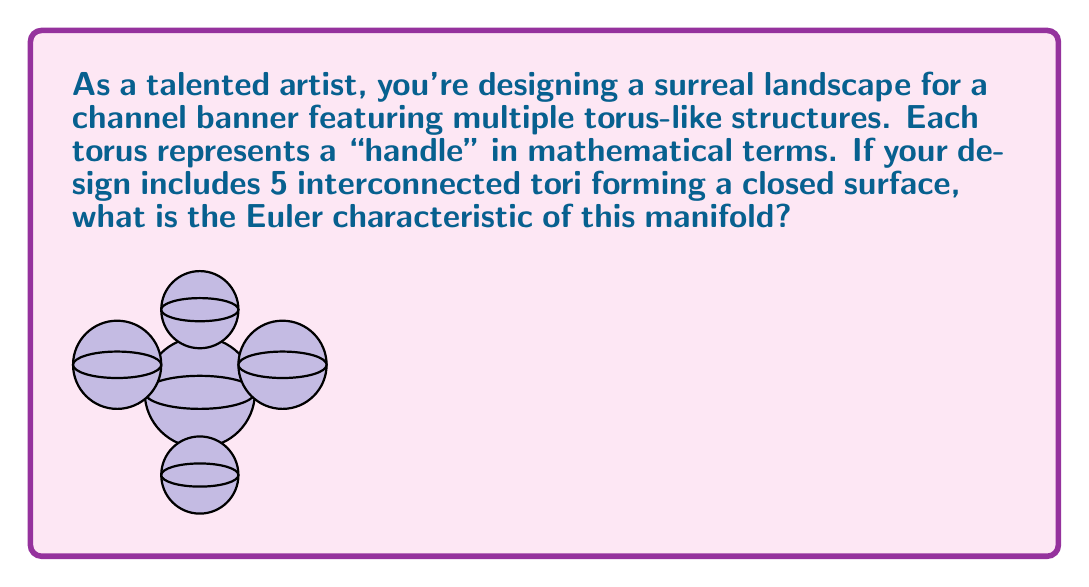What is the answer to this math problem? To solve this problem, let's follow these steps:

1) First, recall the formula for the Euler characteristic of a closed orientable surface:

   $$\chi = 2 - 2g$$

   where $\chi$ is the Euler characteristic and $g$ is the genus (number of handles) of the surface.

2) In this case, we have 5 interconnected tori. Each torus contributes one handle to the overall surface.

3) Therefore, the genus of our surface is:

   $$g = 5$$

4) Now, we can substitute this into our formula:

   $$\chi = 2 - 2(5)$$

5) Simplify:

   $$\chi = 2 - 10 = -8$$

Thus, the Euler characteristic of this closed manifold with 5 handles is -8.
Answer: $-8$ 